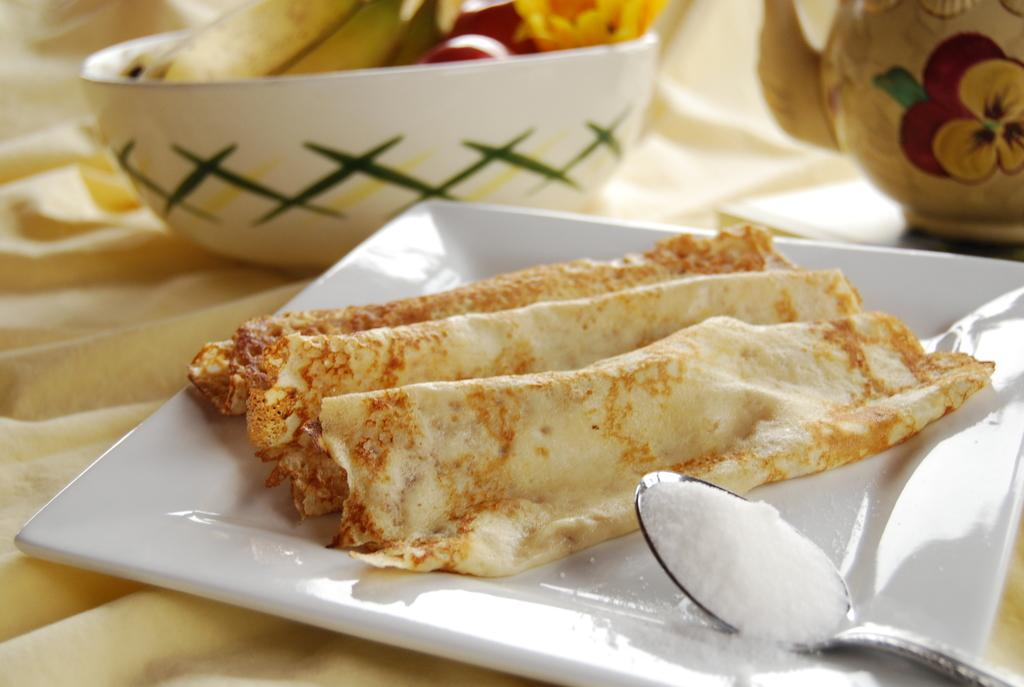What is on the plate in the image? There are food items on a plate in the image. What is in the bowl in the image? There are food items in a bowl in the image. What is the spoon used for in the image? There is a spoon with powder in the image. What is the object that resembles a teapot placed on? There is an object that looks like a teapot on a cloth in the image. What type of locket is being used to serve the meal in the image? There is no locket present in the image, and no meal is being served using a locket. Can you tell me how many people are swimming in the image? There is no swimming activity depicted in the image. 